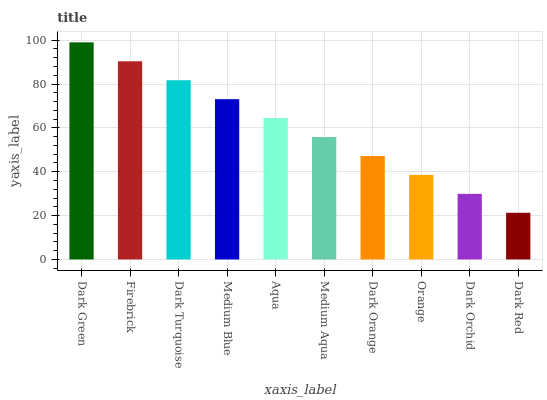Is Dark Red the minimum?
Answer yes or no. Yes. Is Dark Green the maximum?
Answer yes or no. Yes. Is Firebrick the minimum?
Answer yes or no. No. Is Firebrick the maximum?
Answer yes or no. No. Is Dark Green greater than Firebrick?
Answer yes or no. Yes. Is Firebrick less than Dark Green?
Answer yes or no. Yes. Is Firebrick greater than Dark Green?
Answer yes or no. No. Is Dark Green less than Firebrick?
Answer yes or no. No. Is Aqua the high median?
Answer yes or no. Yes. Is Medium Aqua the low median?
Answer yes or no. Yes. Is Dark Orange the high median?
Answer yes or no. No. Is Dark Orchid the low median?
Answer yes or no. No. 